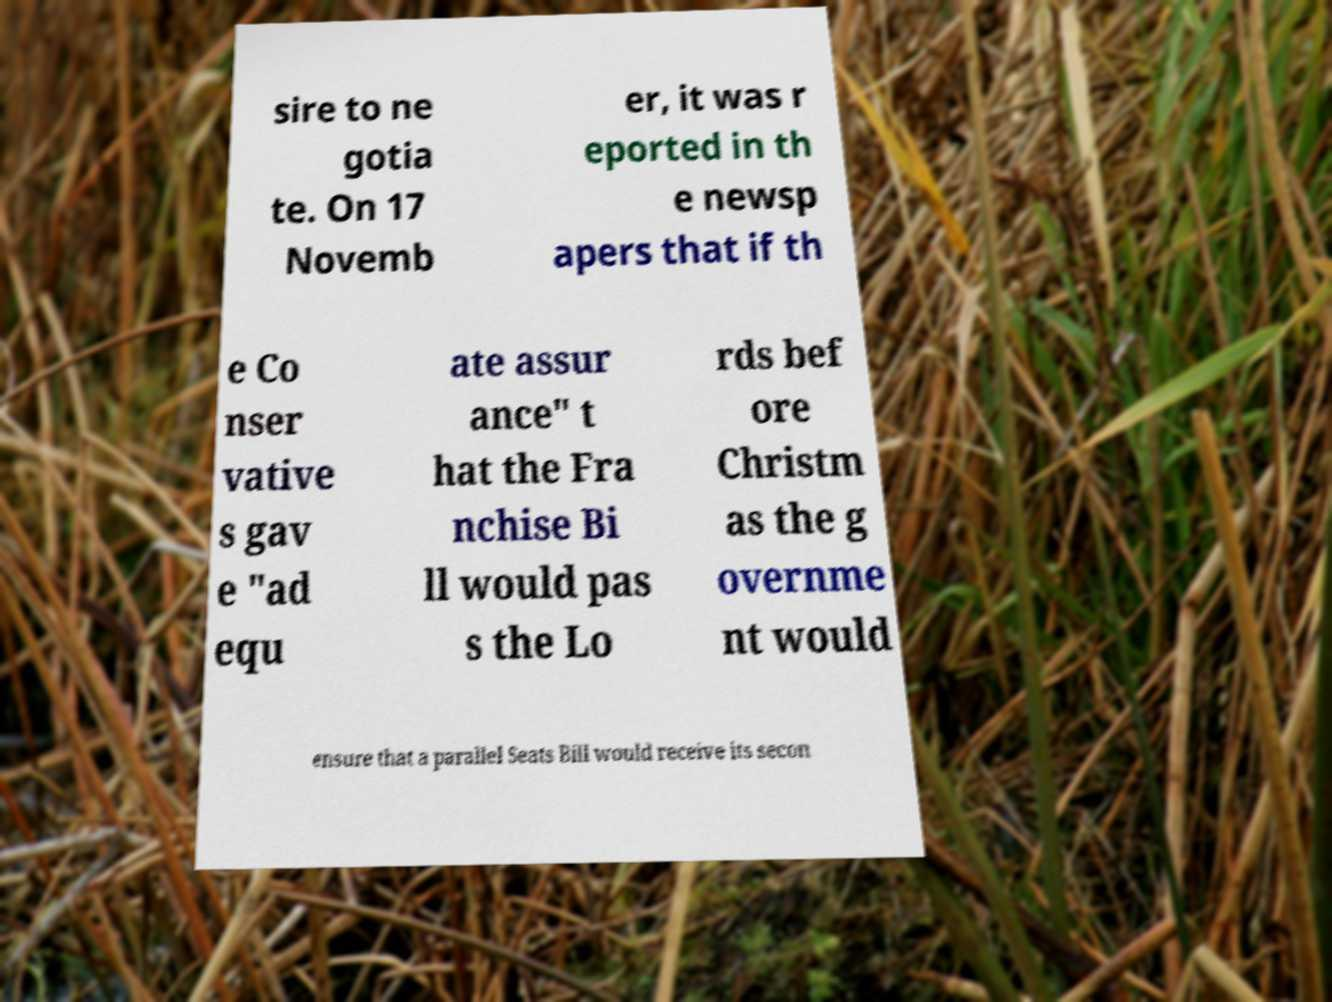Please read and relay the text visible in this image. What does it say? sire to ne gotia te. On 17 Novemb er, it was r eported in th e newsp apers that if th e Co nser vative s gav e "ad equ ate assur ance" t hat the Fra nchise Bi ll would pas s the Lo rds bef ore Christm as the g overnme nt would ensure that a parallel Seats Bill would receive its secon 